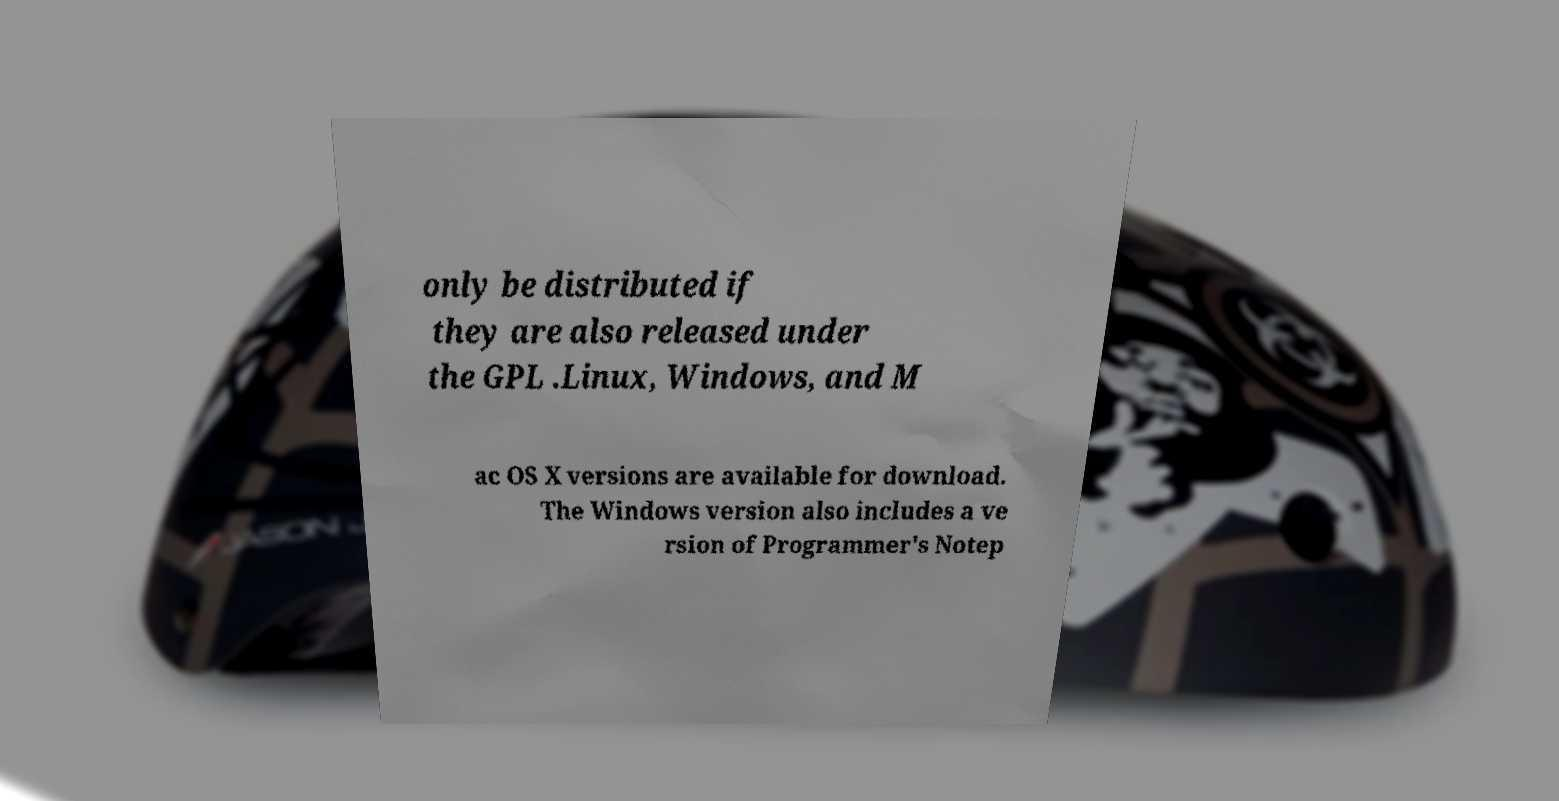I need the written content from this picture converted into text. Can you do that? only be distributed if they are also released under the GPL .Linux, Windows, and M ac OS X versions are available for download. The Windows version also includes a ve rsion of Programmer's Notep 